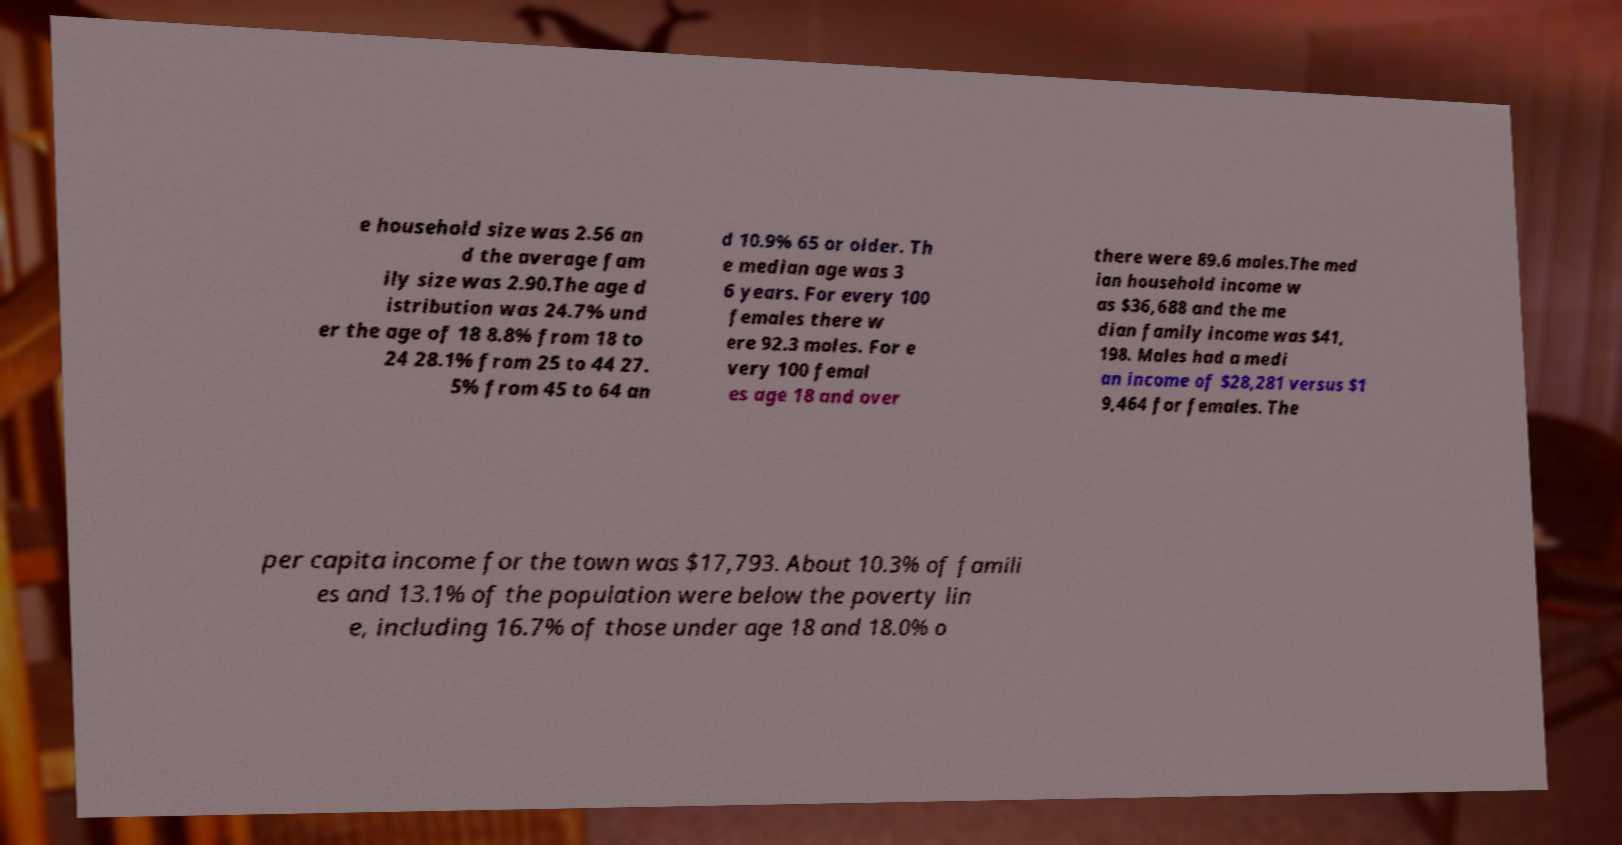Could you extract and type out the text from this image? e household size was 2.56 an d the average fam ily size was 2.90.The age d istribution was 24.7% und er the age of 18 8.8% from 18 to 24 28.1% from 25 to 44 27. 5% from 45 to 64 an d 10.9% 65 or older. Th e median age was 3 6 years. For every 100 females there w ere 92.3 males. For e very 100 femal es age 18 and over there were 89.6 males.The med ian household income w as $36,688 and the me dian family income was $41, 198. Males had a medi an income of $28,281 versus $1 9,464 for females. The per capita income for the town was $17,793. About 10.3% of famili es and 13.1% of the population were below the poverty lin e, including 16.7% of those under age 18 and 18.0% o 